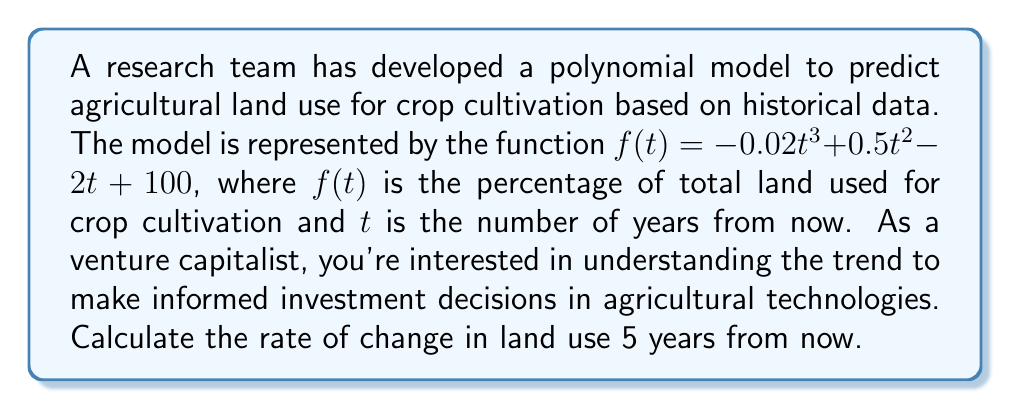Teach me how to tackle this problem. To find the rate of change in land use 5 years from now, we need to calculate the derivative of the given function and evaluate it at $t = 5$. Here's the step-by-step process:

1) The given function is:
   $f(t) = -0.02t^3 + 0.5t^2 - 2t + 100$

2) To find the rate of change, we need to calculate $f'(t)$:
   $f'(t) = -0.06t^2 + t - 2$

3) Now, we need to evaluate $f'(5)$:
   $f'(5) = -0.06(5^2) + 5 - 2$
   $= -0.06(25) + 5 - 2$
   $= -1.5 + 5 - 2$
   $= 1.5$

The rate of change is measured in percentage points per year. A positive value indicates an increasing trend in land use for crop cultivation.
Answer: The rate of change in agricultural land use for crop cultivation 5 years from now will be 1.5 percentage points per year. 